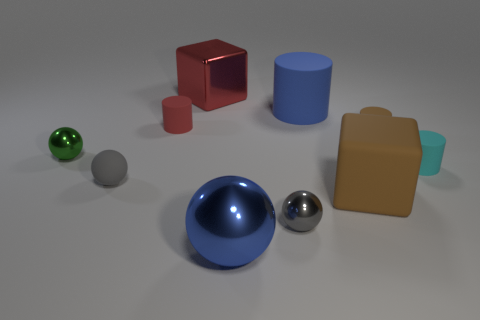What is the shape of the object that is the same color as the large cylinder?
Ensure brevity in your answer.  Sphere. There is a metallic object that is both behind the small rubber sphere and to the right of the green sphere; what is its color?
Offer a very short reply. Red. Is the number of brown cubes to the left of the small rubber sphere greater than the number of small cyan objects left of the cyan matte cylinder?
Keep it short and to the point. No. What is the size of the blue object that is made of the same material as the brown cylinder?
Offer a very short reply. Large. What number of green balls are to the right of the small sphere that is behind the cyan rubber object?
Your answer should be compact. 0. Are there any other big blue things of the same shape as the blue metallic object?
Offer a very short reply. No. What color is the block behind the green thing that is left of the gray rubber object?
Make the answer very short. Red. Is the number of green cylinders greater than the number of big blue matte cylinders?
Offer a terse response. No. How many gray matte objects have the same size as the red metal object?
Ensure brevity in your answer.  0. Are the large brown object and the tiny red cylinder that is on the left side of the large metal block made of the same material?
Keep it short and to the point. Yes. 